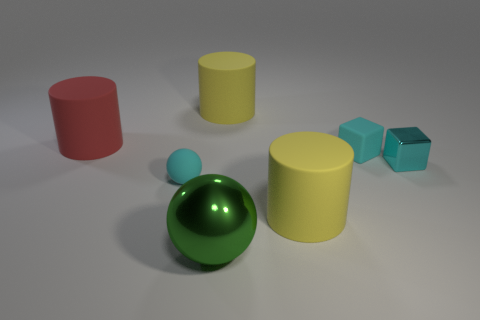Can you describe the colors of the objects in the image? Certainly! There is a red cylinder, a green sphere, a blue cube, a smaller blue sphere, a yellow cylinder, and a yellow cube. 